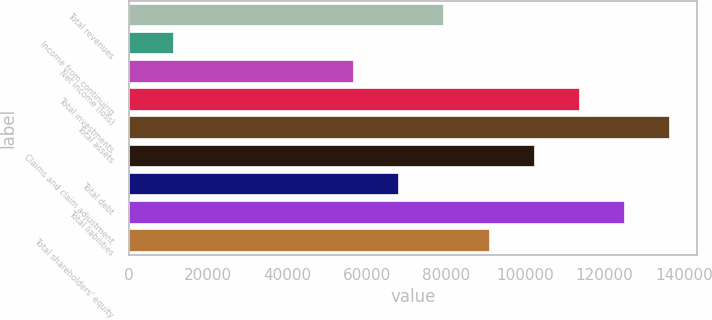<chart> <loc_0><loc_0><loc_500><loc_500><bar_chart><fcel>Total revenues<fcel>Income from continuing<fcel>Net income (loss)<fcel>Total investments<fcel>Total assets<fcel>Claims and claim adjustment<fcel>Total debt<fcel>Total liabilities<fcel>Total shareholders' equity<nl><fcel>79633<fcel>11377<fcel>56881<fcel>113761<fcel>136513<fcel>102385<fcel>68257<fcel>125137<fcel>91009<nl></chart> 